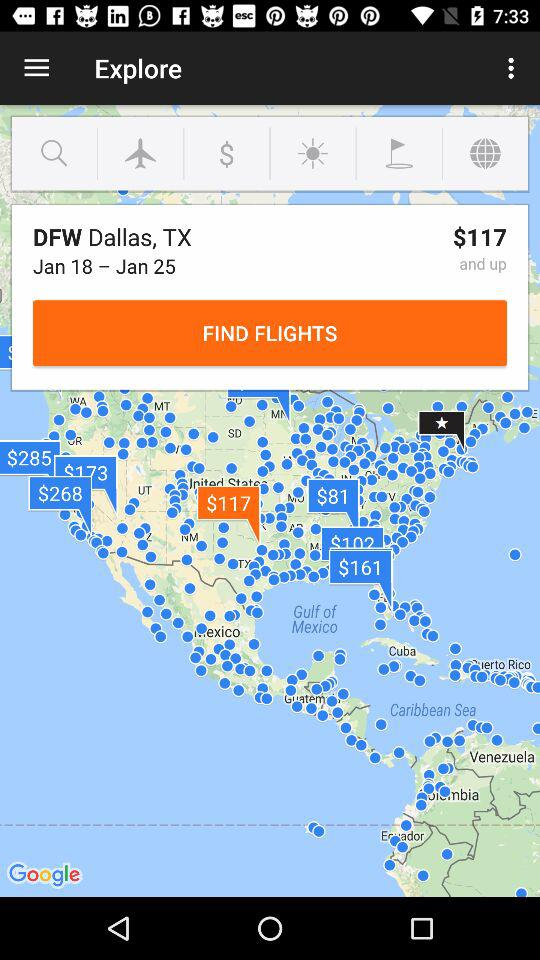What is the fair of "DFW Dallas,TX"? The fair is $117. 